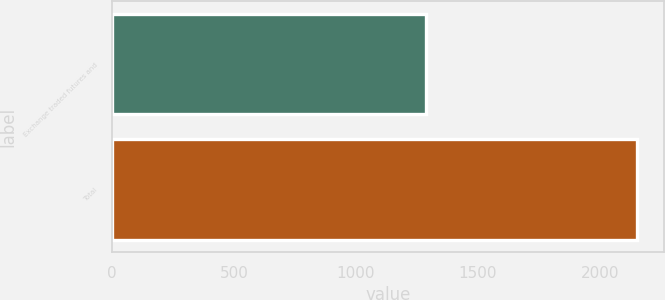Convert chart. <chart><loc_0><loc_0><loc_500><loc_500><bar_chart><fcel>Exchange traded futures and<fcel>Total<nl><fcel>1287<fcel>2154<nl></chart> 